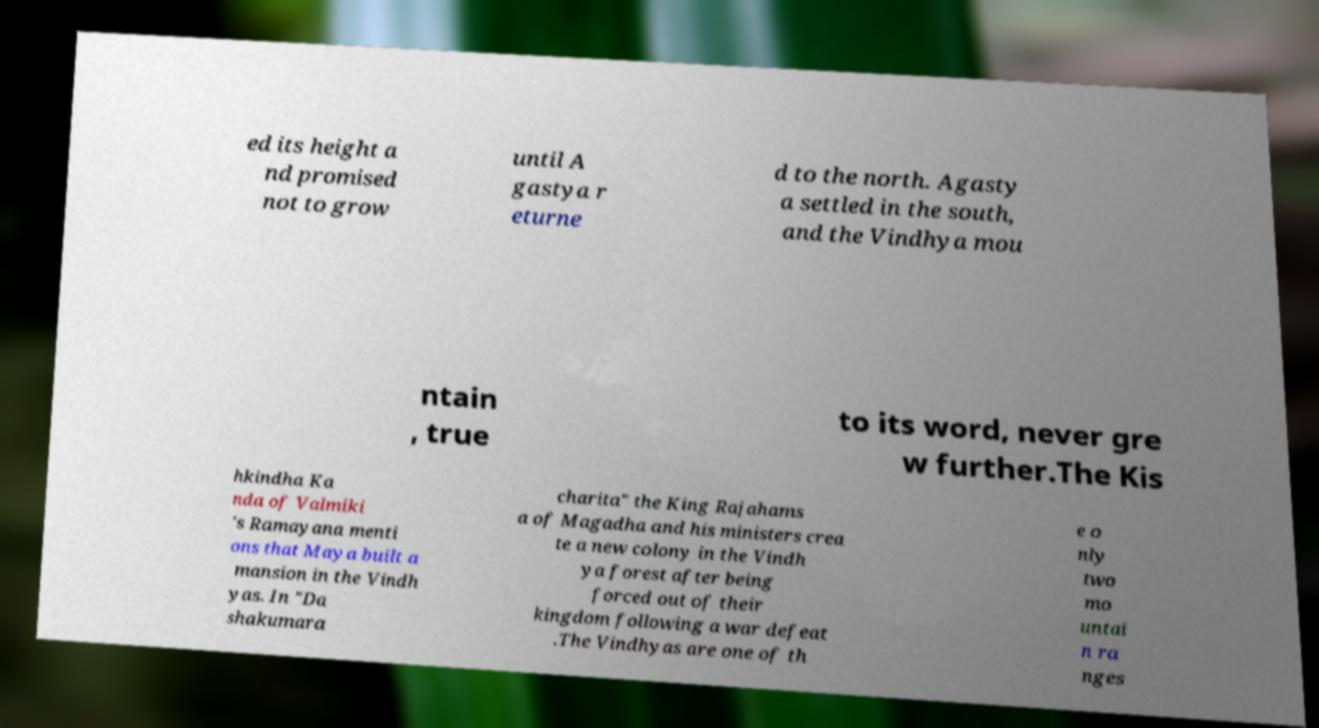Please identify and transcribe the text found in this image. ed its height a nd promised not to grow until A gastya r eturne d to the north. Agasty a settled in the south, and the Vindhya mou ntain , true to its word, never gre w further.The Kis hkindha Ka nda of Valmiki 's Ramayana menti ons that Maya built a mansion in the Vindh yas. In "Da shakumara charita" the King Rajahams a of Magadha and his ministers crea te a new colony in the Vindh ya forest after being forced out of their kingdom following a war defeat .The Vindhyas are one of th e o nly two mo untai n ra nges 